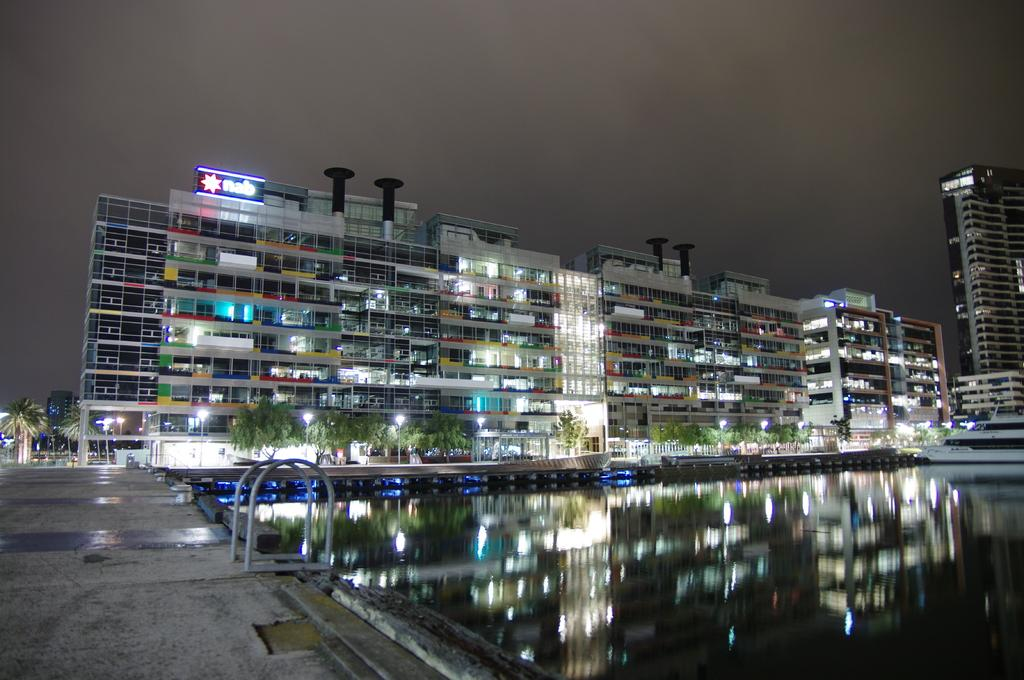What type of structures can be seen in the image? There are buildings in the image. What natural elements are present in the image? There are trees in the image. What mode of transportation is on the water in the image? There is a boat on the water in the image. What type of lighting is present in the image? There are street lights in the image. What can be seen in the background of the image? The sky is visible in the background of the image. What is the cause of the boat folding in half in the image? There is no boat folding in half in the image; the boat is on the water and appears to be in normal condition. 